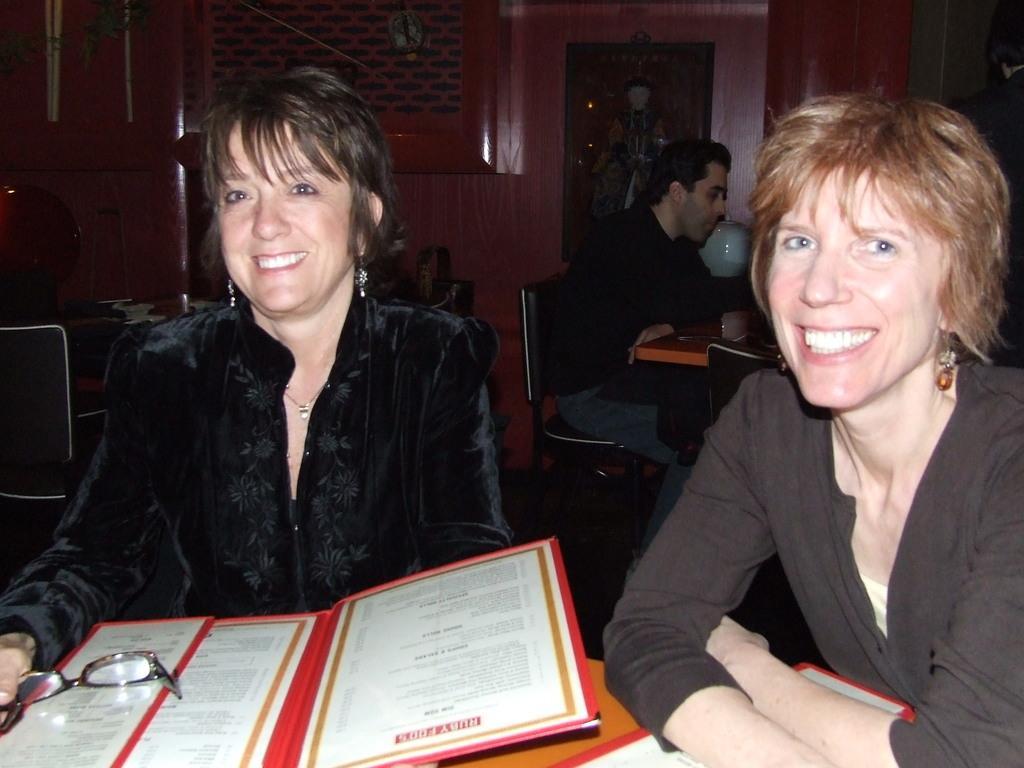Please provide a concise description of this image. There are two women sitting in front of a table in the foreground area of the image, it seems like menu and spectacles on the table, there are other people, frame and other objects in the background. 